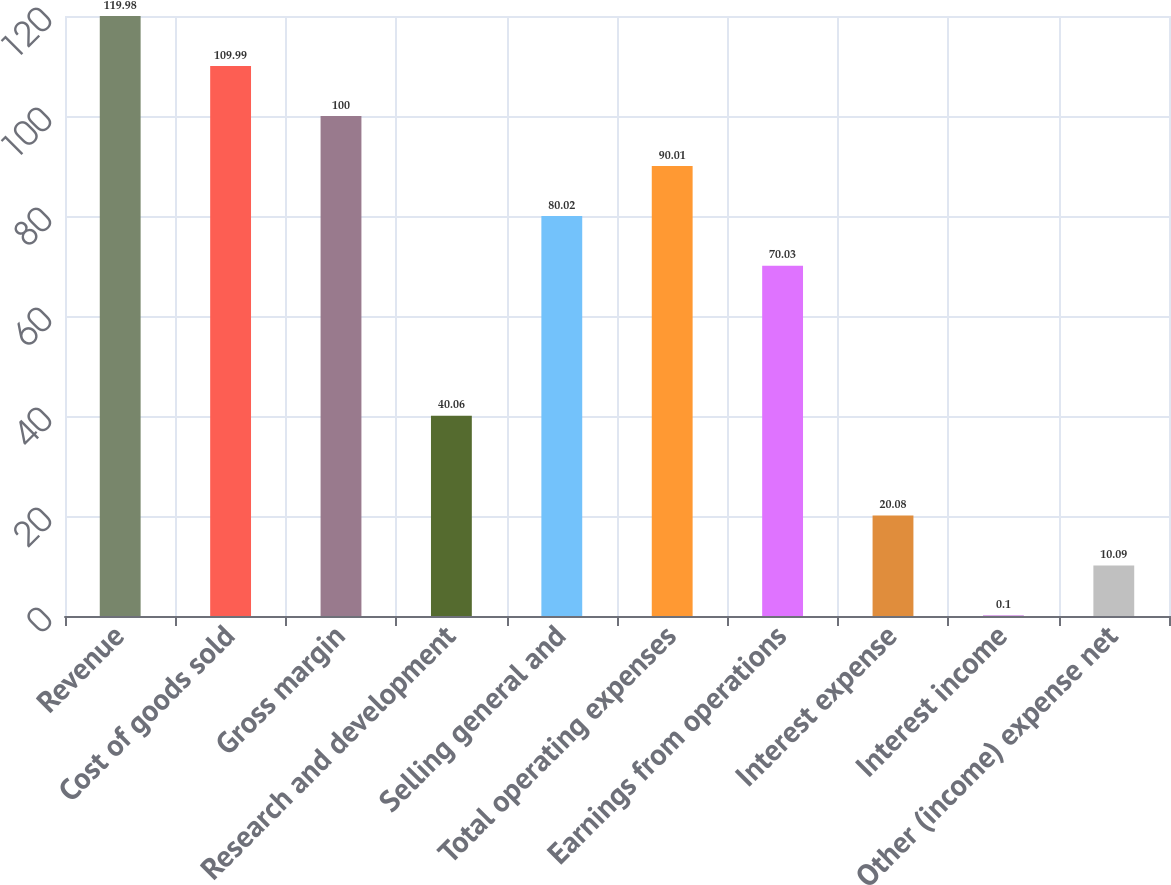Convert chart to OTSL. <chart><loc_0><loc_0><loc_500><loc_500><bar_chart><fcel>Revenue<fcel>Cost of goods sold<fcel>Gross margin<fcel>Research and development<fcel>Selling general and<fcel>Total operating expenses<fcel>Earnings from operations<fcel>Interest expense<fcel>Interest income<fcel>Other (income) expense net<nl><fcel>119.98<fcel>109.99<fcel>100<fcel>40.06<fcel>80.02<fcel>90.01<fcel>70.03<fcel>20.08<fcel>0.1<fcel>10.09<nl></chart> 